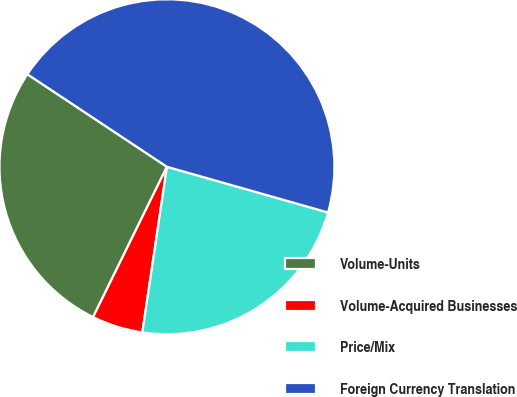Convert chart to OTSL. <chart><loc_0><loc_0><loc_500><loc_500><pie_chart><fcel>Volume-Units<fcel>Volume-Acquired Businesses<fcel>Price/Mix<fcel>Foreign Currency Translation<nl><fcel>27.05%<fcel>4.92%<fcel>22.95%<fcel>45.08%<nl></chart> 